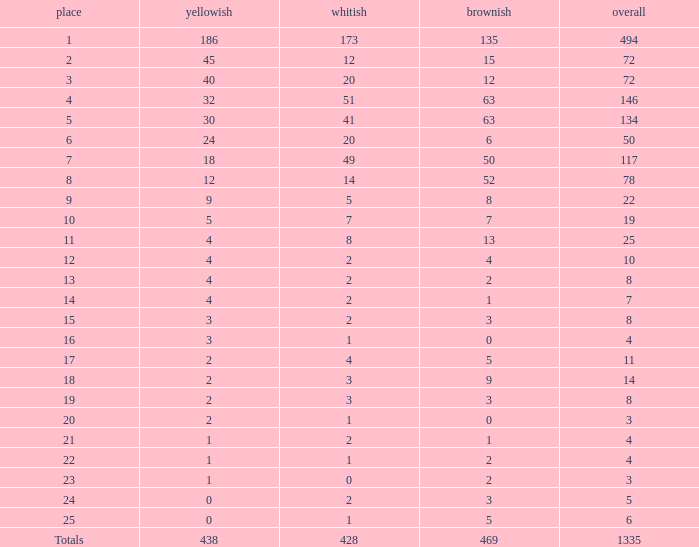What is the total amount of gold medals when there were more than 20 silvers and there were 135 bronze medals? 1.0. 